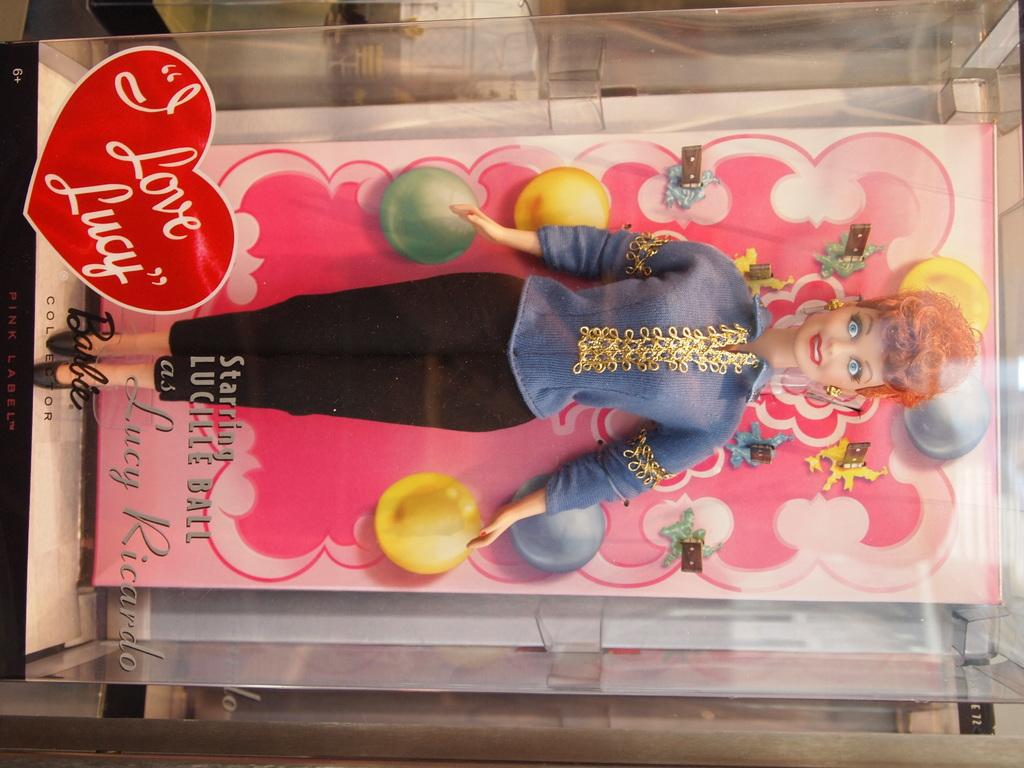What is the main subject of the image? The main subject of the image is a Barbie doll. How is the Barbie doll being stored or displayed? The Barbie doll is kept in a box. What is the Barbie doll wearing? The Barbie doll is wearing a blue shirt and a black pant. Is there any text present in the image? Yes, there is text at the bottom of the image. What type of haircut does the Barbie doll have in the image? The image does not show the Barbie doll's haircut, as it is focused on the doll's clothing and the box it is kept in. Is there any brass material visible in the image? There is no brass material visible in the image. 